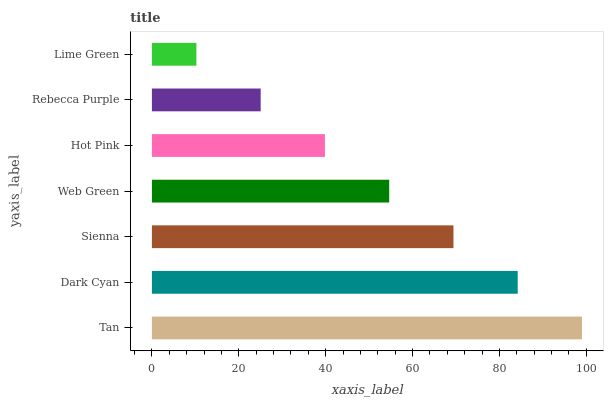Is Lime Green the minimum?
Answer yes or no. Yes. Is Tan the maximum?
Answer yes or no. Yes. Is Dark Cyan the minimum?
Answer yes or no. No. Is Dark Cyan the maximum?
Answer yes or no. No. Is Tan greater than Dark Cyan?
Answer yes or no. Yes. Is Dark Cyan less than Tan?
Answer yes or no. Yes. Is Dark Cyan greater than Tan?
Answer yes or no. No. Is Tan less than Dark Cyan?
Answer yes or no. No. Is Web Green the high median?
Answer yes or no. Yes. Is Web Green the low median?
Answer yes or no. Yes. Is Dark Cyan the high median?
Answer yes or no. No. Is Dark Cyan the low median?
Answer yes or no. No. 